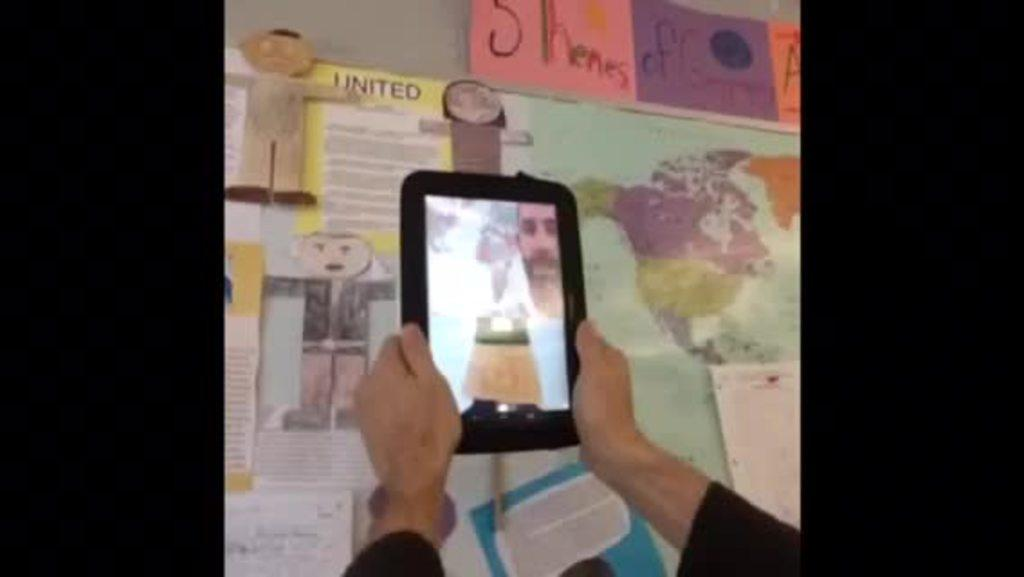Who is present in the image? There is a person in the image. What is the person holding in the image? The person is holding a smartphone with both hands. What can be seen in the background of the image? There are paintings in the backdrop of the image. What is on the notice board in the image? There is a map on a notice board in the image. What rule does the stranger break in the image? There is no stranger present in the image, so it is not possible to determine if any rules are broken. 